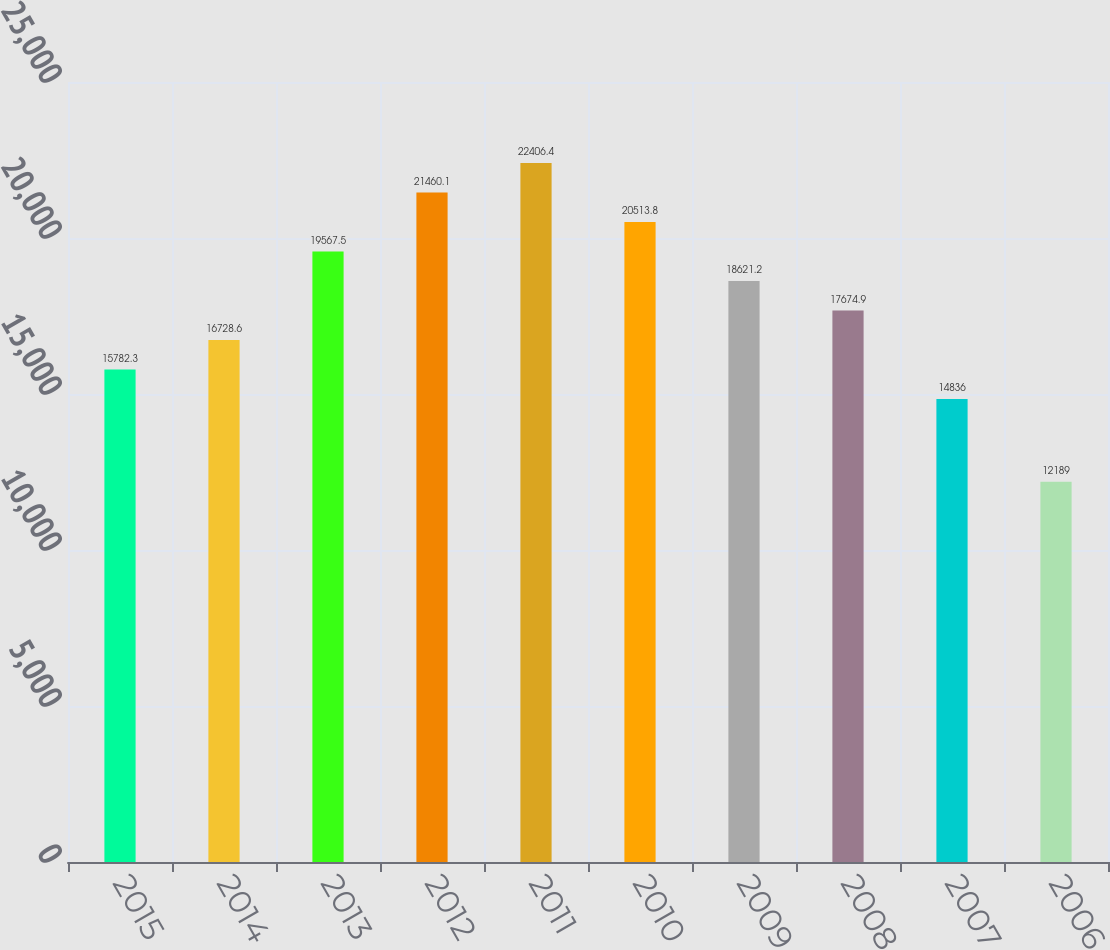Convert chart. <chart><loc_0><loc_0><loc_500><loc_500><bar_chart><fcel>2015<fcel>2014<fcel>2013<fcel>2012<fcel>2011<fcel>2010<fcel>2009<fcel>2008<fcel>2007<fcel>2006<nl><fcel>15782.3<fcel>16728.6<fcel>19567.5<fcel>21460.1<fcel>22406.4<fcel>20513.8<fcel>18621.2<fcel>17674.9<fcel>14836<fcel>12189<nl></chart> 